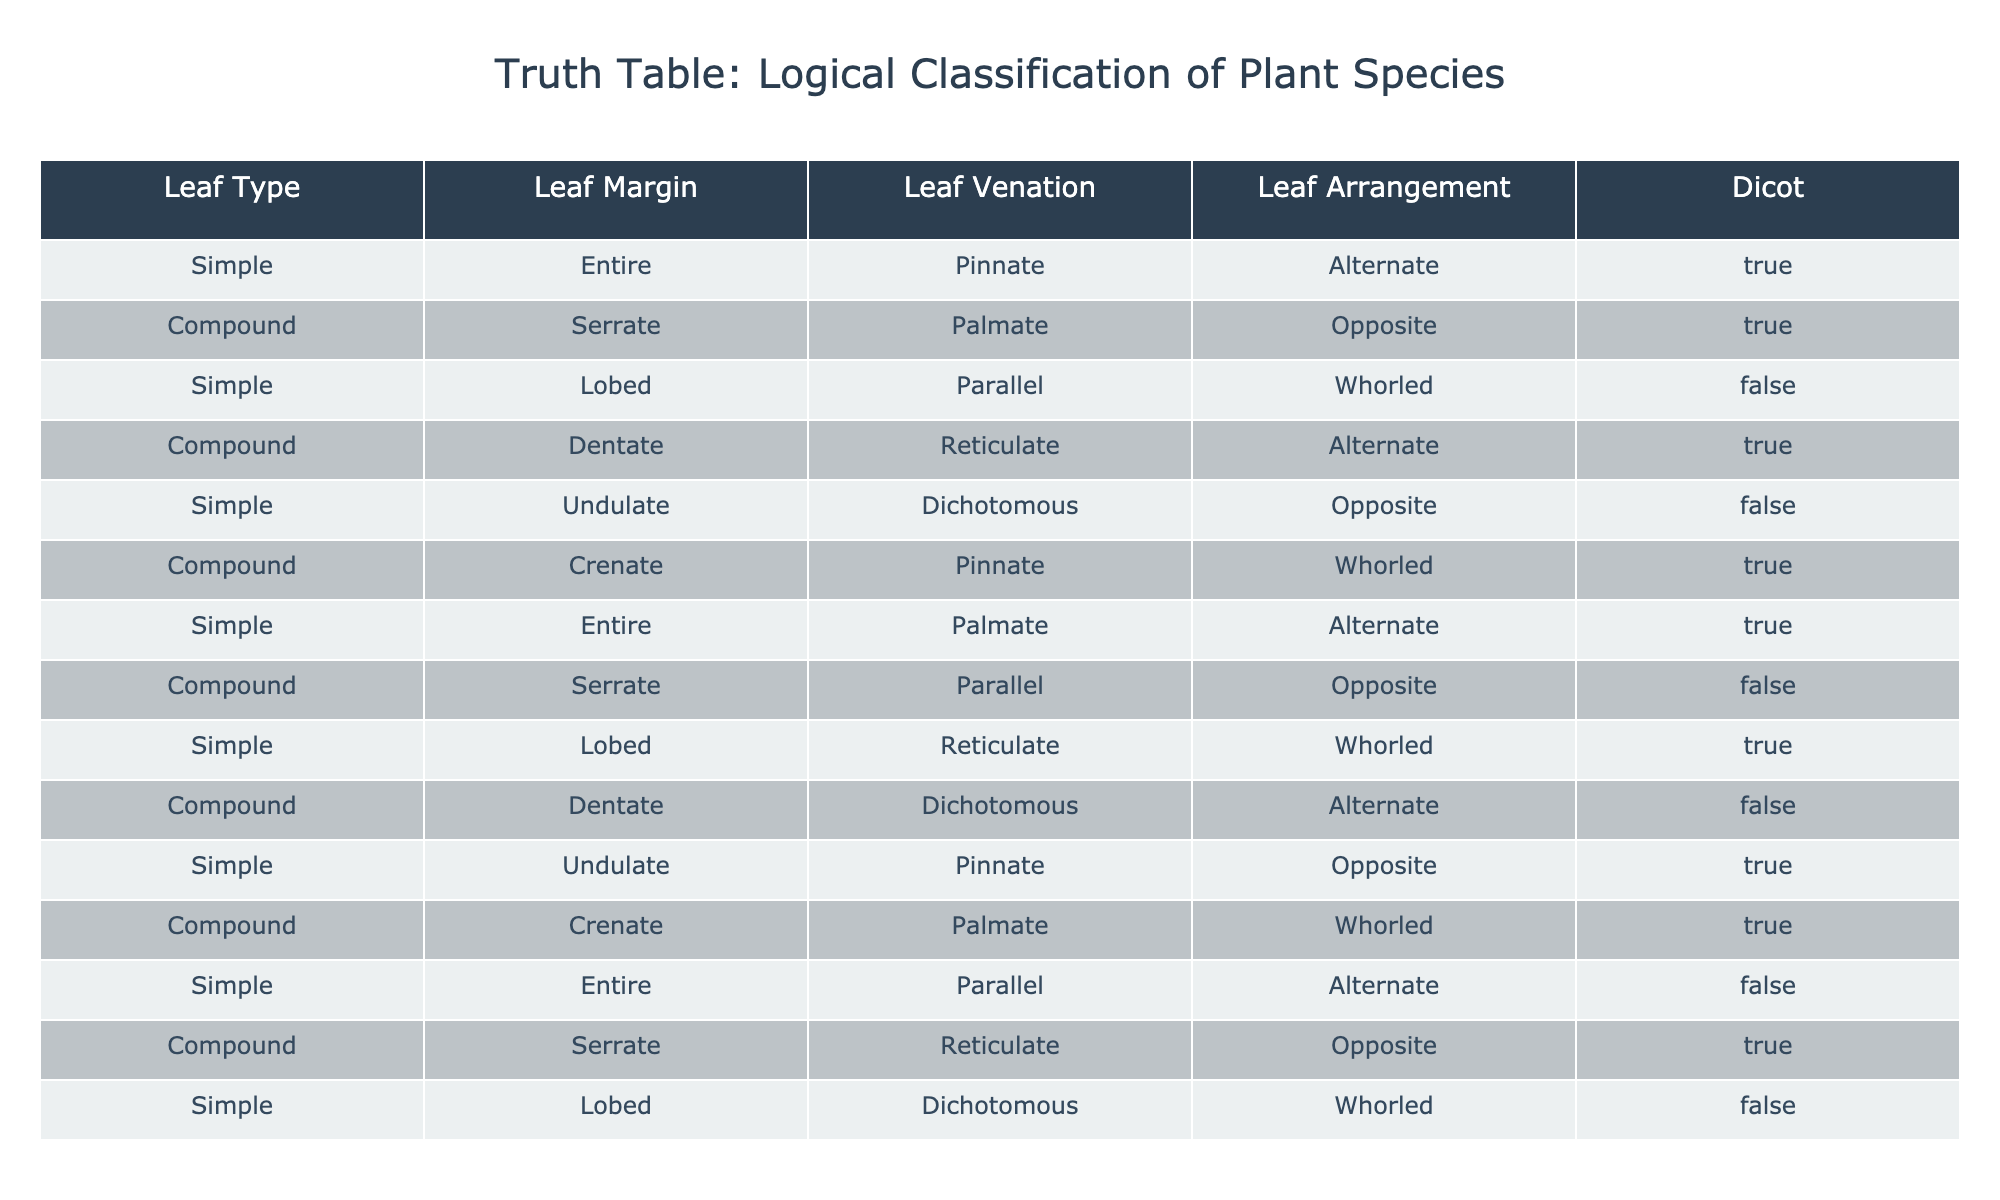What is the number of simple leaves with an entire margin? By examining the table, we specifically look for rows where the Leaf Type is 'Simple' and the Leaf Margin is 'Entire'. There are 3 such rows: the first, seventh, and thirteenth rows.
Answer: 3 How many compound leaves have a serrate margin? We need to identify rows where the Leaf Type is 'Compound' and the Leaf Margin is 'Serrate'. Looking through the table, we find 3 occurrences: the second, eighth, and fourteenth rows.
Answer: 3 Is it true that all simple leaves with a lobed structure are classified as dicots? We check for rows with a Leaf Type of 'Simple', Leaf Margin of 'Lobed', and look at the Dicot classification. Only one occurrence matches, which is the ninth row classified as False. Therefore, it is not true that all simple lobed leaves are dicots.
Answer: No What is the sum of dicots from leaves that are both compound and have a serrate margin? We identify rows with Leaf Type 'Compound' and Leaf Margin 'Serrate'. The relevant rows lead us to the second and fourteenth rows, which have the Dicot classification of True and False respectively. Therefore, summing them leads to 1 (True) + 0 (False) = 1.
Answer: 1 How many total leaf arrangements are classified as whorled among the simple leaves? We look for rows with Leaf Type 'Simple' and Leaf Arrangement 'Whorled'. Checking the table, we find the third, ninth, and thirteenth rows. This results in 3 simple leaves with a whorled arrangement.
Answer: 3 What percentage of the leaves with a parallel veination are classified as dicots? We first locate the rows with Leaf Venation 'Parallel'. The rows include the fifth, eleventh, and thirteenth. Among these, we check the Dicot classification: the fifth row (No), eleventh row (Yes), and thirteenth (No). This means 1 out of 3 is classified as dicots. Thus, the percentage is (1/3) * 100 = approximately 33.33%.
Answer: 33.33% Are there any compound leaves with a dentate margin that are classified as dicots? We must find rows that have Leaf Type 'Compound' and Leaf Margin 'Dentate'. The pertinent rows are the fourth and tenth. The fourth row is classified as True (dicot) and the tenth as False (not dicot). Therefore, yes, at least one exists.
Answer: Yes What is the ratio of simple leaves classified as dicots compared to all dicot leaves? We check the number of simple leaves that are labeled as True in the Dicot classification. Looking through, there are 4 such simple leaves (first, fourth, seventh, and eleventh rows). The total count of dicots in the entire table is 8. Therefore, the ratio is 4:8, which simplifies to 1:2.
Answer: 1:2 